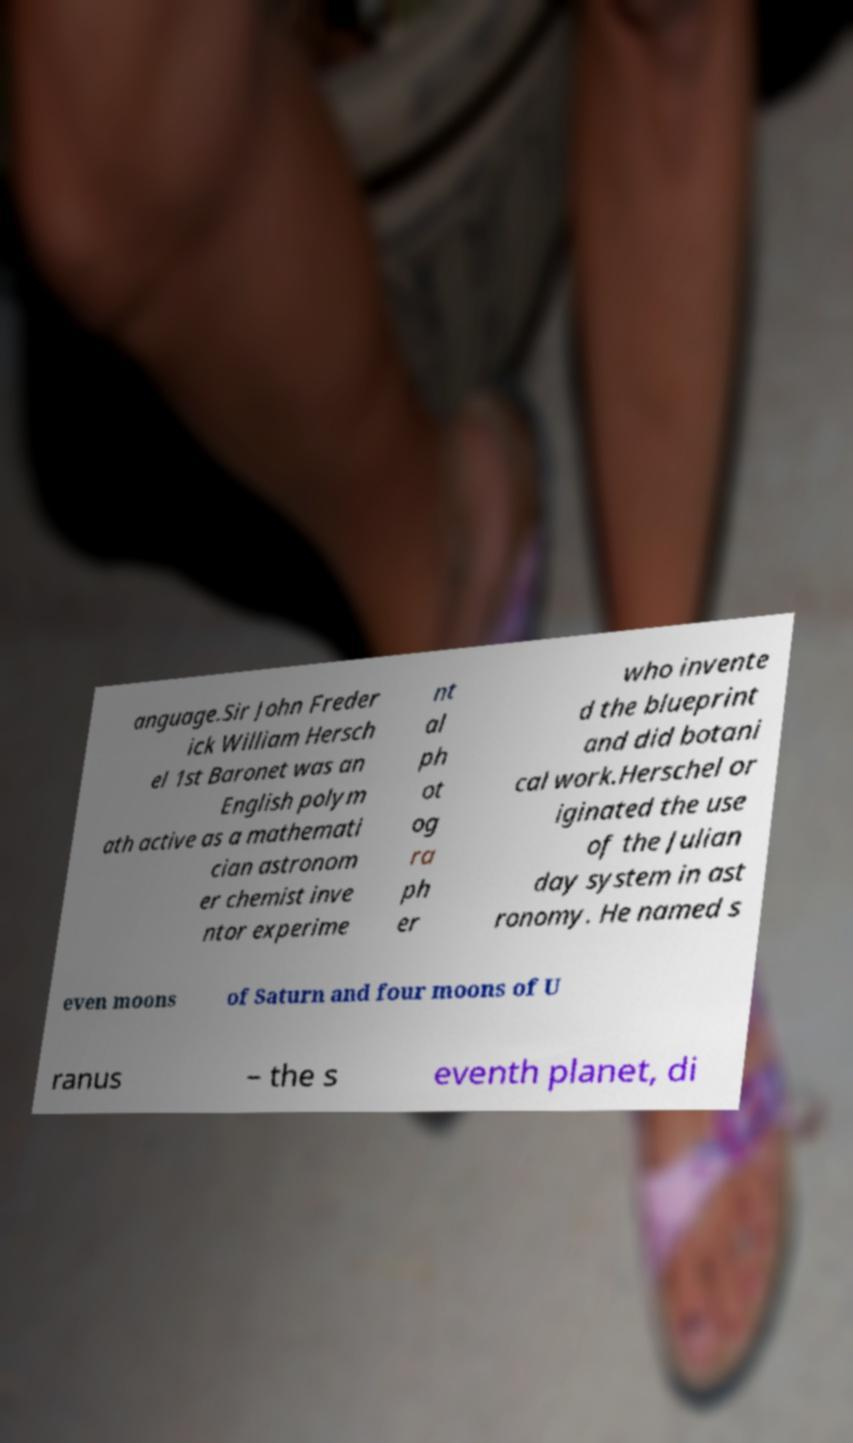Please identify and transcribe the text found in this image. anguage.Sir John Freder ick William Hersch el 1st Baronet was an English polym ath active as a mathemati cian astronom er chemist inve ntor experime nt al ph ot og ra ph er who invente d the blueprint and did botani cal work.Herschel or iginated the use of the Julian day system in ast ronomy. He named s even moons of Saturn and four moons of U ranus – the s eventh planet, di 